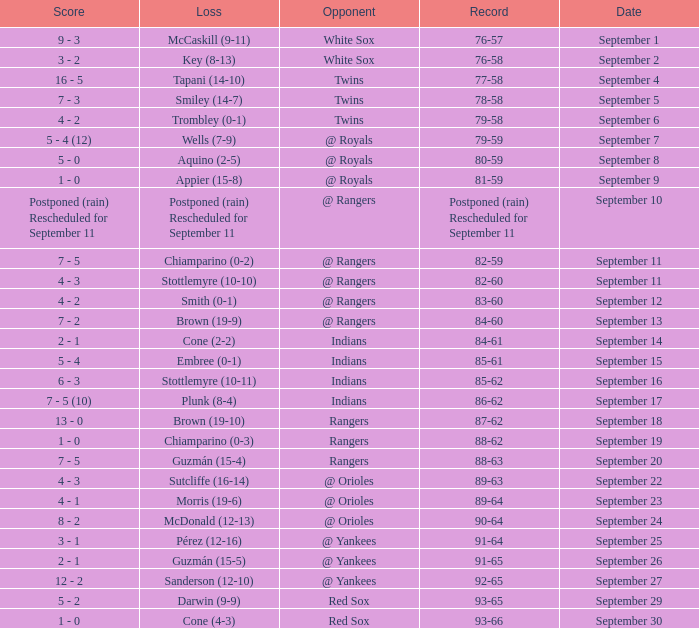What is the outcome of the september 15 match featuring the indians as the opponent? 5 - 4. 